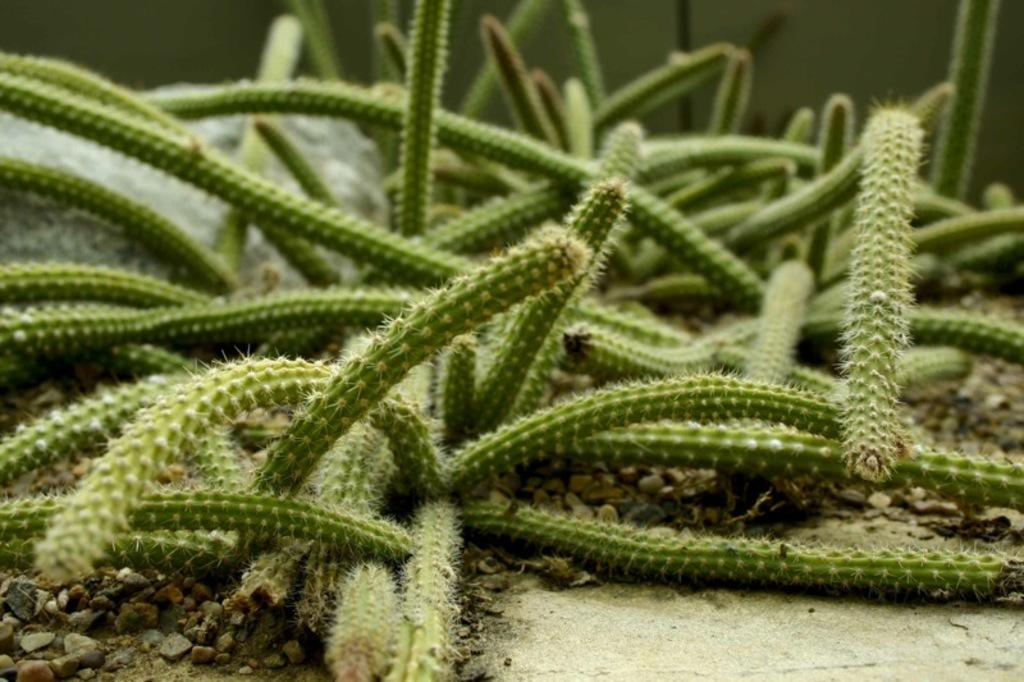What type of plants are visible in the image? There are cactus plants in the image. Can you tell me how many horses are standing next to the cactus plants in the image? There are no horses present in the image; it only features cactus plants. What type of bottle is placed on the wrist of the person in the image? There is no person or bottle present in the image; it only features cactus plants. 